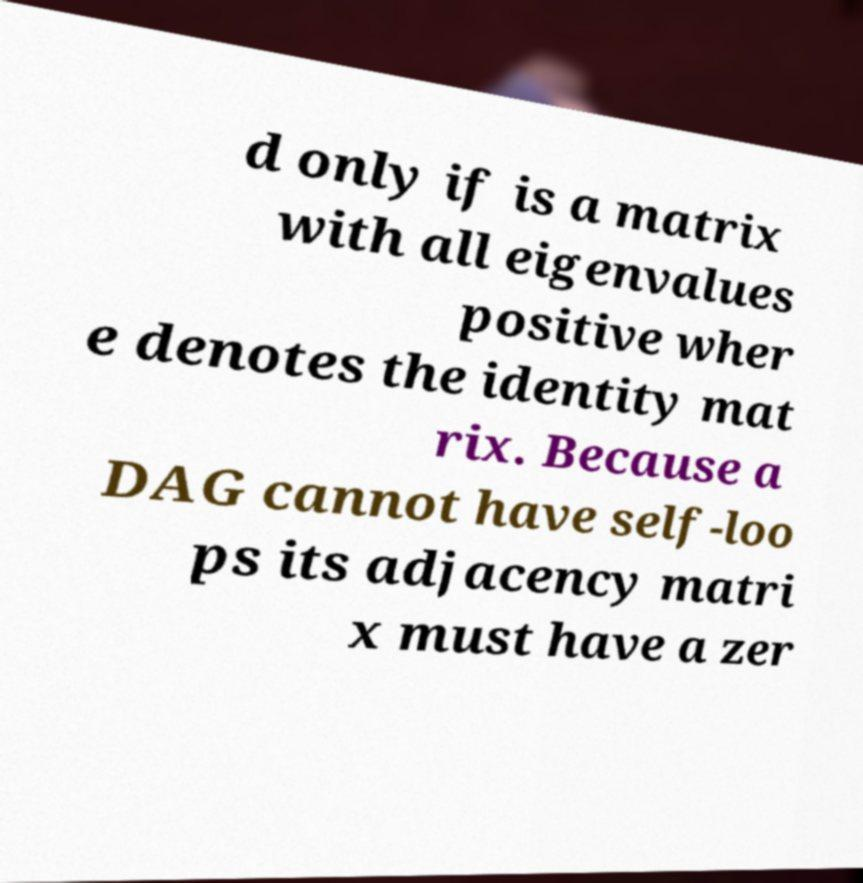For documentation purposes, I need the text within this image transcribed. Could you provide that? d only if is a matrix with all eigenvalues positive wher e denotes the identity mat rix. Because a DAG cannot have self-loo ps its adjacency matri x must have a zer 